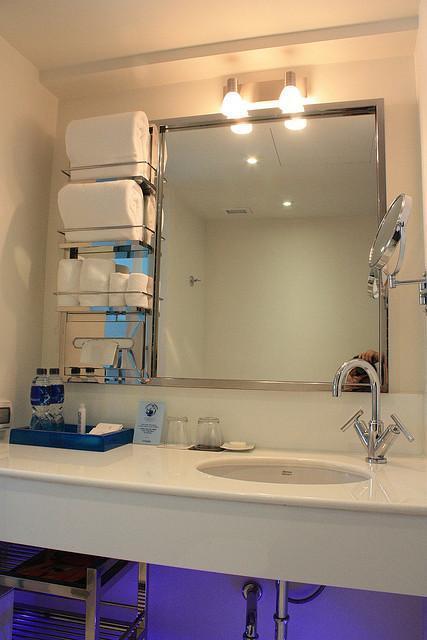How many green bikes are in the picture?
Give a very brief answer. 0. 